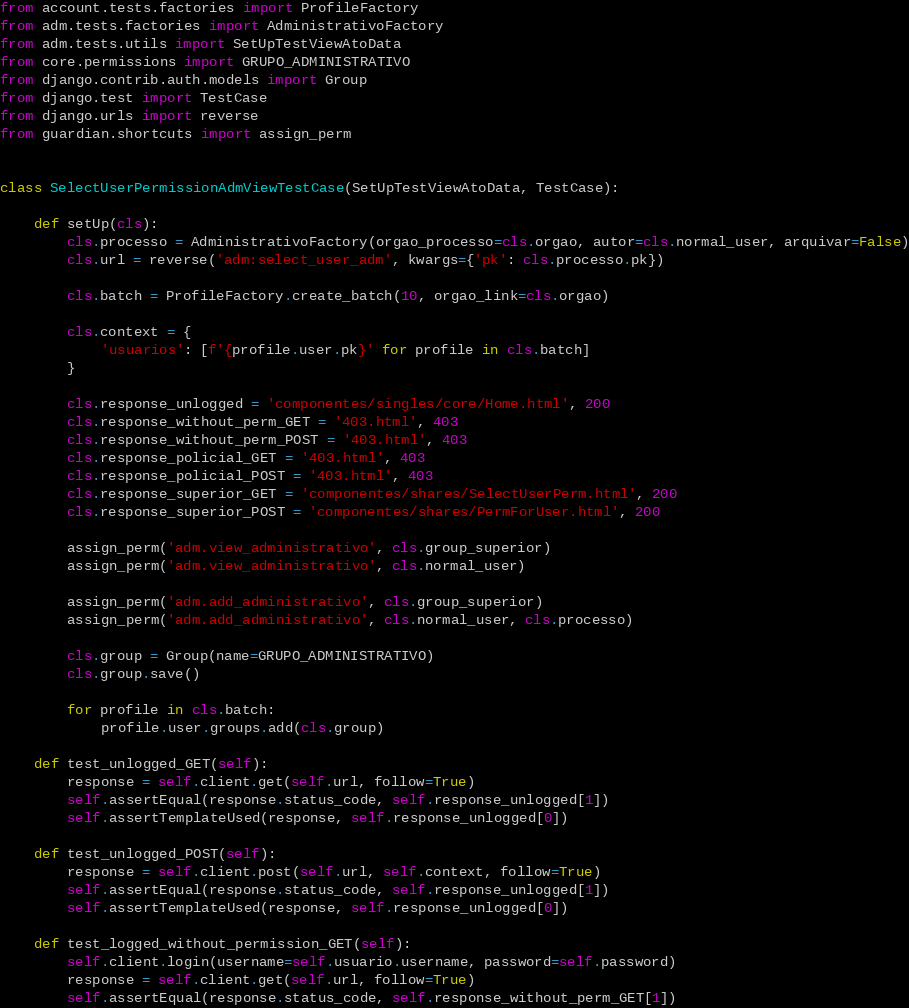Convert code to text. <code><loc_0><loc_0><loc_500><loc_500><_Python_>
from account.tests.factories import ProfileFactory
from adm.tests.factories import AdministrativoFactory
from adm.tests.utils import SetUpTestViewAtoData
from core.permissions import GRUPO_ADMINISTRATIVO
from django.contrib.auth.models import Group
from django.test import TestCase
from django.urls import reverse
from guardian.shortcuts import assign_perm


class SelectUserPermissionAdmViewTestCase(SetUpTestViewAtoData, TestCase):

    def setUp(cls):
        cls.processo = AdministrativoFactory(orgao_processo=cls.orgao, autor=cls.normal_user, arquivar=False)
        cls.url = reverse('adm:select_user_adm', kwargs={'pk': cls.processo.pk})

        cls.batch = ProfileFactory.create_batch(10, orgao_link=cls.orgao)

        cls.context = {
            'usuarios': [f'{profile.user.pk}' for profile in cls.batch]
        }

        cls.response_unlogged = 'componentes/singles/core/Home.html', 200
        cls.response_without_perm_GET = '403.html', 403
        cls.response_without_perm_POST = '403.html', 403
        cls.response_policial_GET = '403.html', 403
        cls.response_policial_POST = '403.html', 403
        cls.response_superior_GET = 'componentes/shares/SelectUserPerm.html', 200
        cls.response_superior_POST = 'componentes/shares/PermForUser.html', 200

        assign_perm('adm.view_administrativo', cls.group_superior)
        assign_perm('adm.view_administrativo', cls.normal_user)

        assign_perm('adm.add_administrativo', cls.group_superior)
        assign_perm('adm.add_administrativo', cls.normal_user, cls.processo)

        cls.group = Group(name=GRUPO_ADMINISTRATIVO)
        cls.group.save()

        for profile in cls.batch:
            profile.user.groups.add(cls.group)

    def test_unlogged_GET(self):
        response = self.client.get(self.url, follow=True)
        self.assertEqual(response.status_code, self.response_unlogged[1])
        self.assertTemplateUsed(response, self.response_unlogged[0])

    def test_unlogged_POST(self):
        response = self.client.post(self.url, self.context, follow=True)
        self.assertEqual(response.status_code, self.response_unlogged[1])
        self.assertTemplateUsed(response, self.response_unlogged[0])

    def test_logged_without_permission_GET(self):
        self.client.login(username=self.usuario.username, password=self.password)
        response = self.client.get(self.url, follow=True)
        self.assertEqual(response.status_code, self.response_without_perm_GET[1])</code> 